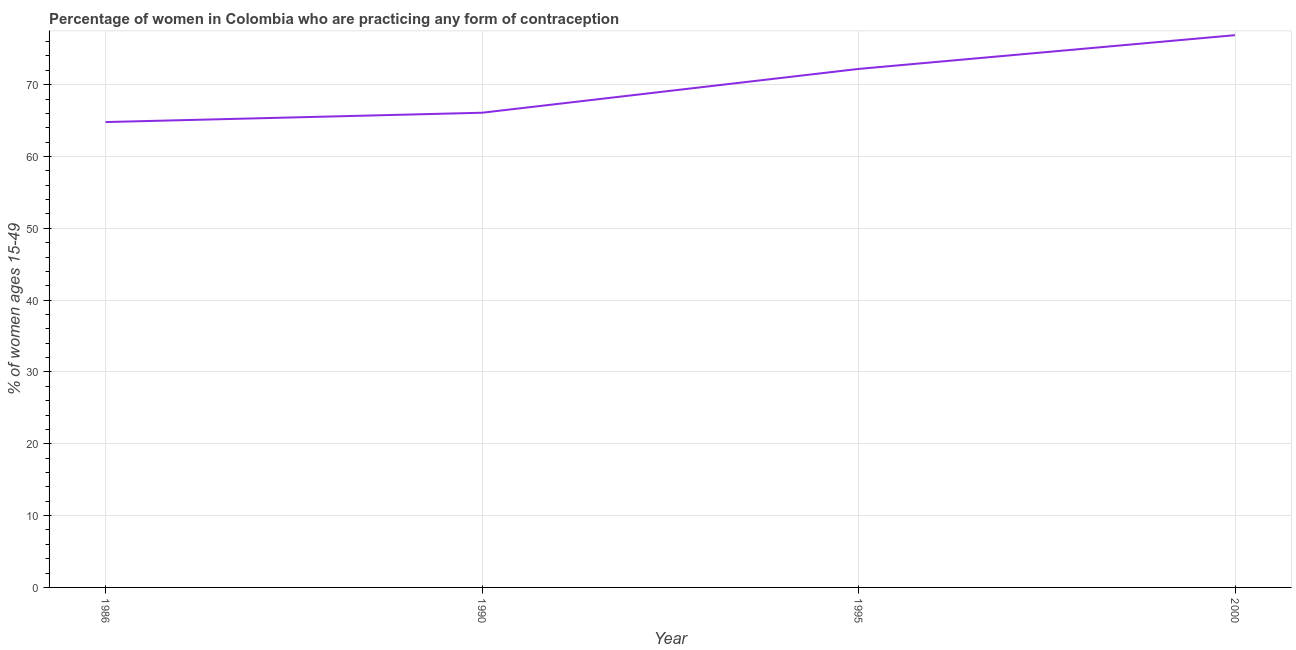What is the contraceptive prevalence in 1986?
Keep it short and to the point. 64.8. Across all years, what is the maximum contraceptive prevalence?
Your answer should be very brief. 76.9. Across all years, what is the minimum contraceptive prevalence?
Provide a succinct answer. 64.8. In which year was the contraceptive prevalence minimum?
Your answer should be compact. 1986. What is the sum of the contraceptive prevalence?
Your response must be concise. 280. What is the difference between the contraceptive prevalence in 1986 and 1995?
Your answer should be very brief. -7.4. What is the average contraceptive prevalence per year?
Your response must be concise. 70. What is the median contraceptive prevalence?
Your response must be concise. 69.15. What is the ratio of the contraceptive prevalence in 1990 to that in 1995?
Keep it short and to the point. 0.92. What is the difference between the highest and the second highest contraceptive prevalence?
Provide a succinct answer. 4.7. Is the sum of the contraceptive prevalence in 1986 and 1995 greater than the maximum contraceptive prevalence across all years?
Keep it short and to the point. Yes. What is the difference between the highest and the lowest contraceptive prevalence?
Ensure brevity in your answer.  12.1. Does the contraceptive prevalence monotonically increase over the years?
Make the answer very short. Yes. What is the difference between two consecutive major ticks on the Y-axis?
Provide a short and direct response. 10. Does the graph contain any zero values?
Offer a terse response. No. What is the title of the graph?
Provide a succinct answer. Percentage of women in Colombia who are practicing any form of contraception. What is the label or title of the Y-axis?
Offer a terse response. % of women ages 15-49. What is the % of women ages 15-49 in 1986?
Provide a succinct answer. 64.8. What is the % of women ages 15-49 in 1990?
Offer a terse response. 66.1. What is the % of women ages 15-49 in 1995?
Provide a short and direct response. 72.2. What is the % of women ages 15-49 of 2000?
Give a very brief answer. 76.9. What is the difference between the % of women ages 15-49 in 1986 and 1995?
Your answer should be compact. -7.4. What is the difference between the % of women ages 15-49 in 1986 and 2000?
Your answer should be compact. -12.1. What is the difference between the % of women ages 15-49 in 1990 and 2000?
Your answer should be compact. -10.8. What is the difference between the % of women ages 15-49 in 1995 and 2000?
Give a very brief answer. -4.7. What is the ratio of the % of women ages 15-49 in 1986 to that in 1995?
Give a very brief answer. 0.9. What is the ratio of the % of women ages 15-49 in 1986 to that in 2000?
Offer a very short reply. 0.84. What is the ratio of the % of women ages 15-49 in 1990 to that in 1995?
Your response must be concise. 0.92. What is the ratio of the % of women ages 15-49 in 1990 to that in 2000?
Provide a short and direct response. 0.86. What is the ratio of the % of women ages 15-49 in 1995 to that in 2000?
Provide a succinct answer. 0.94. 